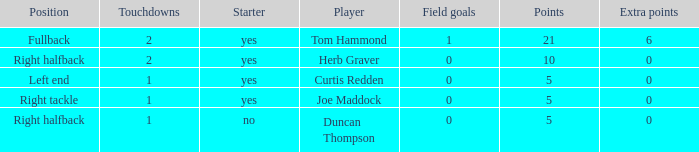Name the number of points for field goals being 1 1.0. 